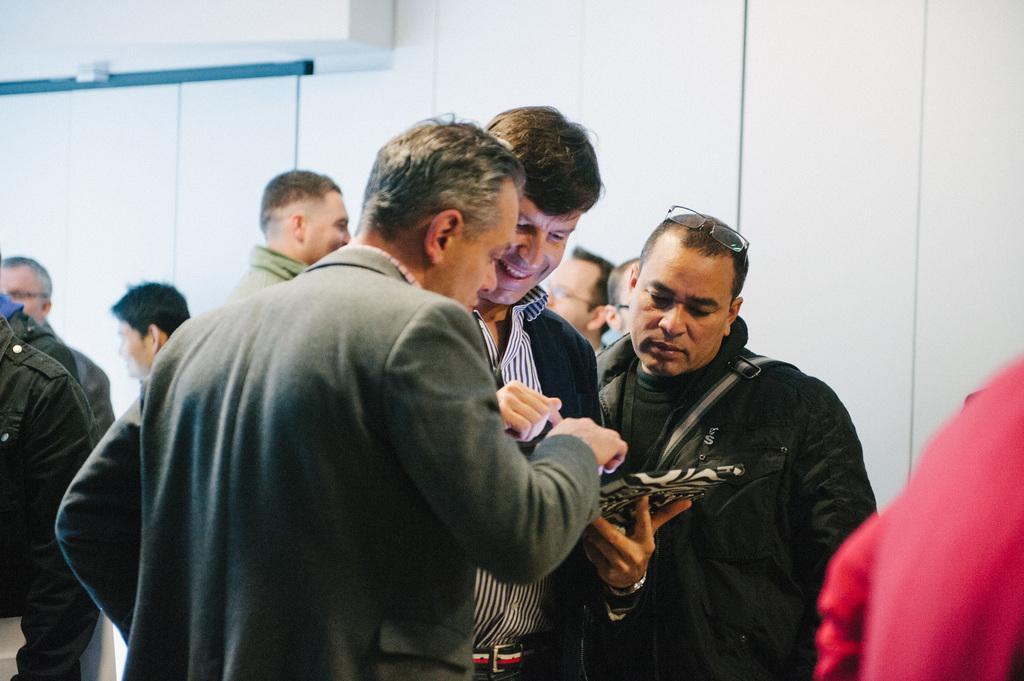In one or two sentences, can you explain what this image depicts? In front of the picture, we see three men are standing. The man in the middle of the picture wearing black jacket is smiling. He is holding a tablet in his hand. Beside him, the man in grey blazer is trying to show something in the tablet. Behind them, we see many people are standing. In the background, we see a wall which is white in color. 